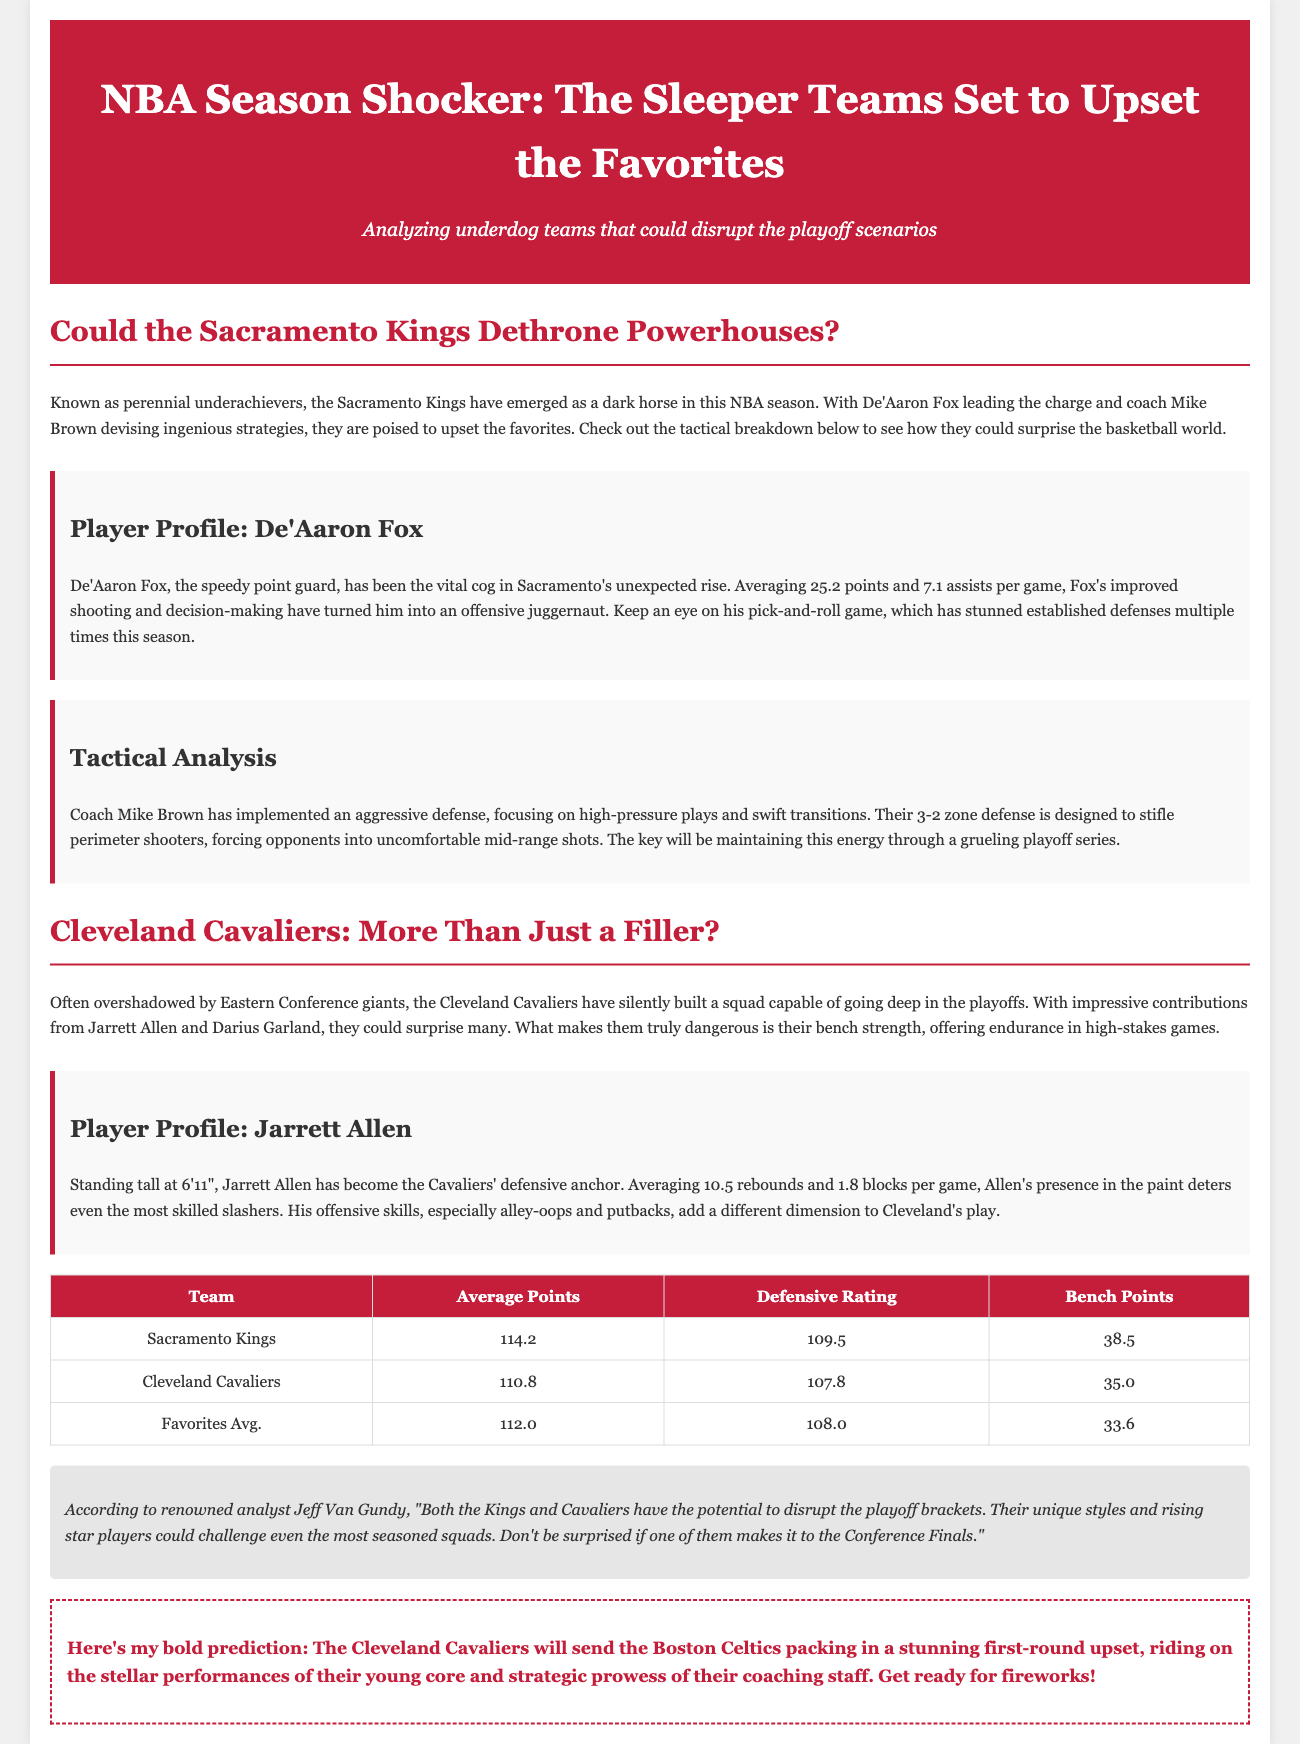What is the subtitle of the article? The subtitle provides a brief overview of the article's focus on underdog teams in the NBA season.
Answer: Analyzing underdog teams that could disrupt the playoff scenarios Who is the leading player for the Sacramento Kings? The player profile highlights De'Aaron Fox as the key player for the Kings, involved in their success.
Answer: De'Aaron Fox What is Jarrett Allen's height? The player profile states his height as part of his physical attributes and role on the team.
Answer: 6'11" What is the average points scored by the Sacramento Kings? The chart provides statistical information on the team's performance, listing their average points per game.
Answer: 114.2 Which team is predicted to upset the Boston Celtics? The opinionated take makes a bold prediction regarding a specific matchup in the playoffs.
Answer: Cleveland Cavaliers What is the Cavaliers' defensive rating? The chart shows different metrics for the team, including their performance on defense.
Answer: 107.8 Who provided the expert opinion in the article? The document mentions a well-known analyst who shares insights about the teams discussed.
Answer: Jeff Van Gundy What is the total bench points for the Sacramento Kings? The chart specifies performance data, including their contribution off the bench.
Answer: 38.5 What tactical approach is highlighted for the Kings? The tactical breakdown details the coaching strategy being executed by the Kings.
Answer: Aggressive defense 